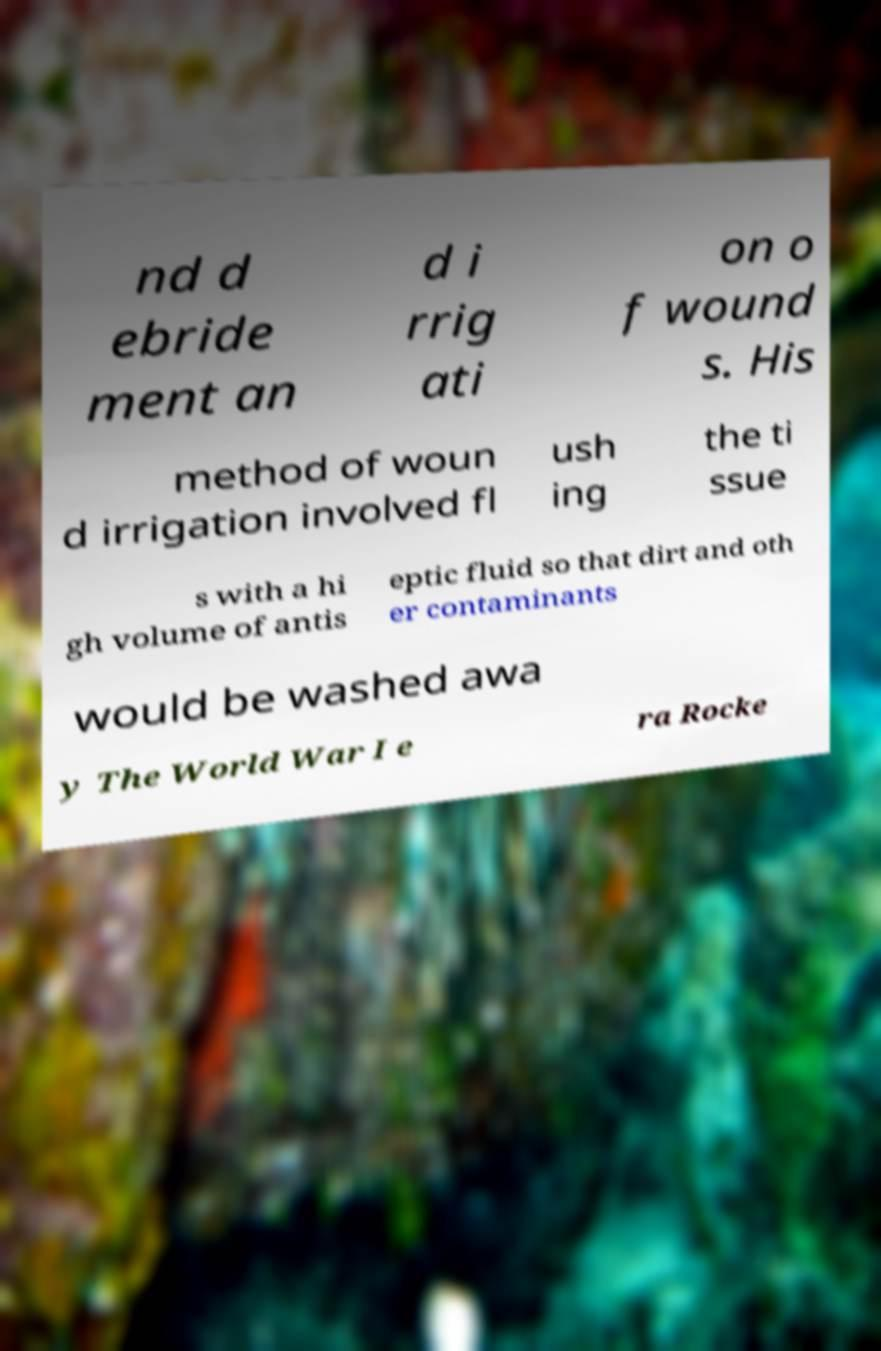I need the written content from this picture converted into text. Can you do that? nd d ebride ment an d i rrig ati on o f wound s. His method of woun d irrigation involved fl ush ing the ti ssue s with a hi gh volume of antis eptic fluid so that dirt and oth er contaminants would be washed awa y The World War I e ra Rocke 